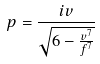<formula> <loc_0><loc_0><loc_500><loc_500>p = \frac { i v } { \sqrt { 6 - \frac { v ^ { 7 } } { f ^ { 7 } } } }</formula> 